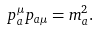Convert formula to latex. <formula><loc_0><loc_0><loc_500><loc_500>p ^ { \mu } _ { a } p _ { a \mu } = m _ { a } ^ { 2 } .</formula> 